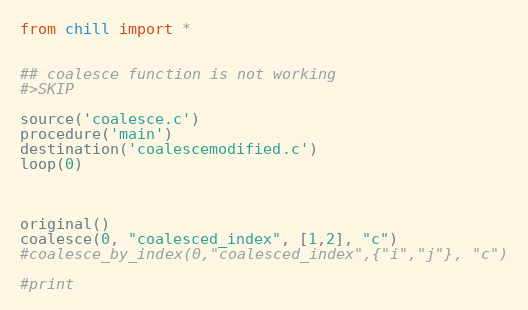<code> <loc_0><loc_0><loc_500><loc_500><_Python_>from chill import *


## coalesce function is not working
#>SKIP

source('coalesce.c')
procedure('main')
destination('coalescemodified.c')
loop(0)



original()
coalesce(0, "coalesced_index", [1,2], "c")
#coalesce_by_index(0,"coalesced_index",{"i","j"}, "c")

#print
</code> 